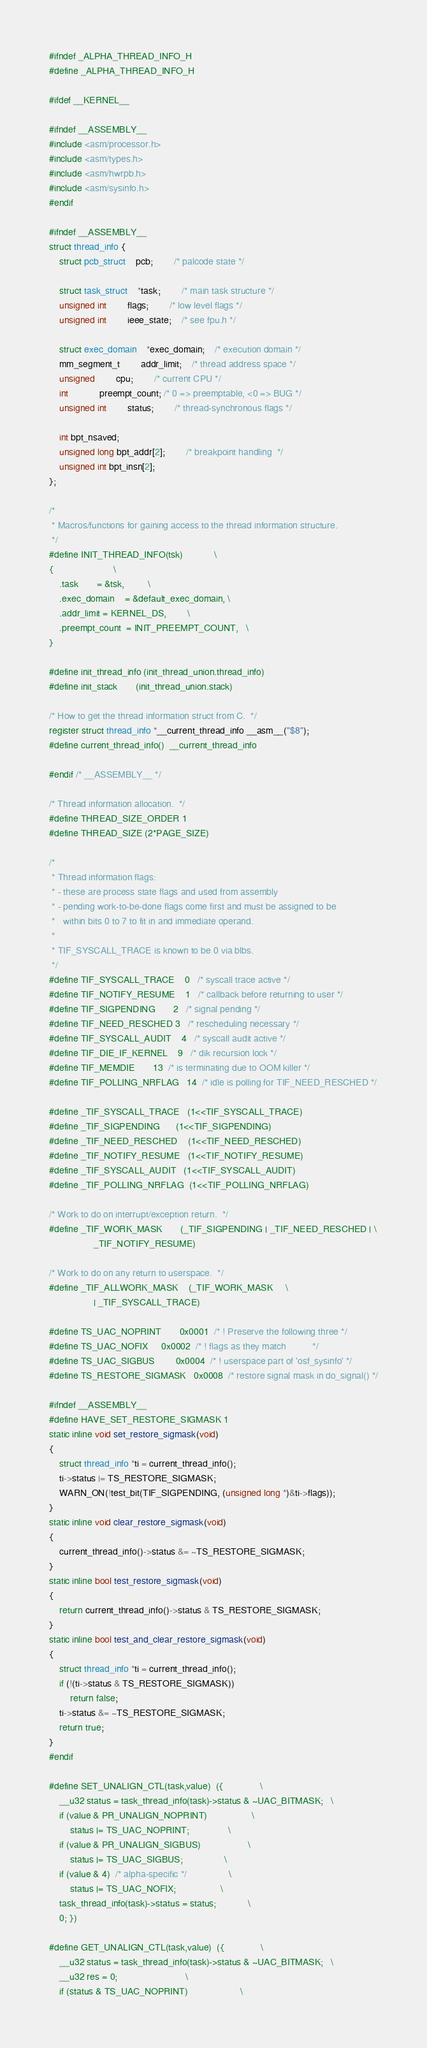<code> <loc_0><loc_0><loc_500><loc_500><_C_>#ifndef _ALPHA_THREAD_INFO_H
#define _ALPHA_THREAD_INFO_H

#ifdef __KERNEL__

#ifndef __ASSEMBLY__
#include <asm/processor.h>
#include <asm/types.h>
#include <asm/hwrpb.h>
#include <asm/sysinfo.h>
#endif

#ifndef __ASSEMBLY__
struct thread_info {
	struct pcb_struct	pcb;		/* palcode state */

	struct task_struct	*task;		/* main task structure */
	unsigned int		flags;		/* low level flags */
	unsigned int		ieee_state;	/* see fpu.h */

	struct exec_domain	*exec_domain;	/* execution domain */
	mm_segment_t		addr_limit;	/* thread address space */
	unsigned		cpu;		/* current CPU */
	int			preempt_count; /* 0 => preemptable, <0 => BUG */
	unsigned int		status;		/* thread-synchronous flags */

	int bpt_nsaved;
	unsigned long bpt_addr[2];		/* breakpoint handling  */
	unsigned int bpt_insn[2];
};

/*
 * Macros/functions for gaining access to the thread information structure.
 */
#define INIT_THREAD_INFO(tsk)			\
{						\
	.task		= &tsk,			\
	.exec_domain	= &default_exec_domain,	\
	.addr_limit	= KERNEL_DS,		\
	.preempt_count	= INIT_PREEMPT_COUNT,	\
}

#define init_thread_info	(init_thread_union.thread_info)
#define init_stack		(init_thread_union.stack)

/* How to get the thread information struct from C.  */
register struct thread_info *__current_thread_info __asm__("$8");
#define current_thread_info()  __current_thread_info

#endif /* __ASSEMBLY__ */

/* Thread information allocation.  */
#define THREAD_SIZE_ORDER 1
#define THREAD_SIZE (2*PAGE_SIZE)

/*
 * Thread information flags:
 * - these are process state flags and used from assembly
 * - pending work-to-be-done flags come first and must be assigned to be
 *   within bits 0 to 7 to fit in and immediate operand.
 *
 * TIF_SYSCALL_TRACE is known to be 0 via blbs.
 */
#define TIF_SYSCALL_TRACE	0	/* syscall trace active */
#define TIF_NOTIFY_RESUME	1	/* callback before returning to user */
#define TIF_SIGPENDING		2	/* signal pending */
#define TIF_NEED_RESCHED	3	/* rescheduling necessary */
#define TIF_SYSCALL_AUDIT	4	/* syscall audit active */
#define TIF_DIE_IF_KERNEL	9	/* dik recursion lock */
#define TIF_MEMDIE		13	/* is terminating due to OOM killer */
#define TIF_POLLING_NRFLAG	14	/* idle is polling for TIF_NEED_RESCHED */

#define _TIF_SYSCALL_TRACE	(1<<TIF_SYSCALL_TRACE)
#define _TIF_SIGPENDING		(1<<TIF_SIGPENDING)
#define _TIF_NEED_RESCHED	(1<<TIF_NEED_RESCHED)
#define _TIF_NOTIFY_RESUME	(1<<TIF_NOTIFY_RESUME)
#define _TIF_SYSCALL_AUDIT	(1<<TIF_SYSCALL_AUDIT)
#define _TIF_POLLING_NRFLAG	(1<<TIF_POLLING_NRFLAG)

/* Work to do on interrupt/exception return.  */
#define _TIF_WORK_MASK		(_TIF_SIGPENDING | _TIF_NEED_RESCHED | \
				 _TIF_NOTIFY_RESUME)

/* Work to do on any return to userspace.  */
#define _TIF_ALLWORK_MASK	(_TIF_WORK_MASK		\
				 | _TIF_SYSCALL_TRACE)

#define TS_UAC_NOPRINT		0x0001	/* ! Preserve the following three */
#define TS_UAC_NOFIX		0x0002	/* ! flags as they match          */
#define TS_UAC_SIGBUS		0x0004	/* ! userspace part of 'osf_sysinfo' */
#define TS_RESTORE_SIGMASK	0x0008	/* restore signal mask in do_signal() */

#ifndef __ASSEMBLY__
#define HAVE_SET_RESTORE_SIGMASK	1
static inline void set_restore_sigmask(void)
{
	struct thread_info *ti = current_thread_info();
	ti->status |= TS_RESTORE_SIGMASK;
	WARN_ON(!test_bit(TIF_SIGPENDING, (unsigned long *)&ti->flags));
}
static inline void clear_restore_sigmask(void)
{
	current_thread_info()->status &= ~TS_RESTORE_SIGMASK;
}
static inline bool test_restore_sigmask(void)
{
	return current_thread_info()->status & TS_RESTORE_SIGMASK;
}
static inline bool test_and_clear_restore_sigmask(void)
{
	struct thread_info *ti = current_thread_info();
	if (!(ti->status & TS_RESTORE_SIGMASK))
		return false;
	ti->status &= ~TS_RESTORE_SIGMASK;
	return true;
}
#endif

#define SET_UNALIGN_CTL(task,value)	({				\
	__u32 status = task_thread_info(task)->status & ~UAC_BITMASK;	\
	if (value & PR_UNALIGN_NOPRINT)					\
		status |= TS_UAC_NOPRINT;				\
	if (value & PR_UNALIGN_SIGBUS)					\
		status |= TS_UAC_SIGBUS;				\
	if (value & 4)	/* alpha-specific */				\
		status |= TS_UAC_NOFIX;					\
	task_thread_info(task)->status = status;			\
	0; })

#define GET_UNALIGN_CTL(task,value)	({				\
	__u32 status = task_thread_info(task)->status & ~UAC_BITMASK;	\
	__u32 res = 0;							\
	if (status & TS_UAC_NOPRINT)					\</code> 